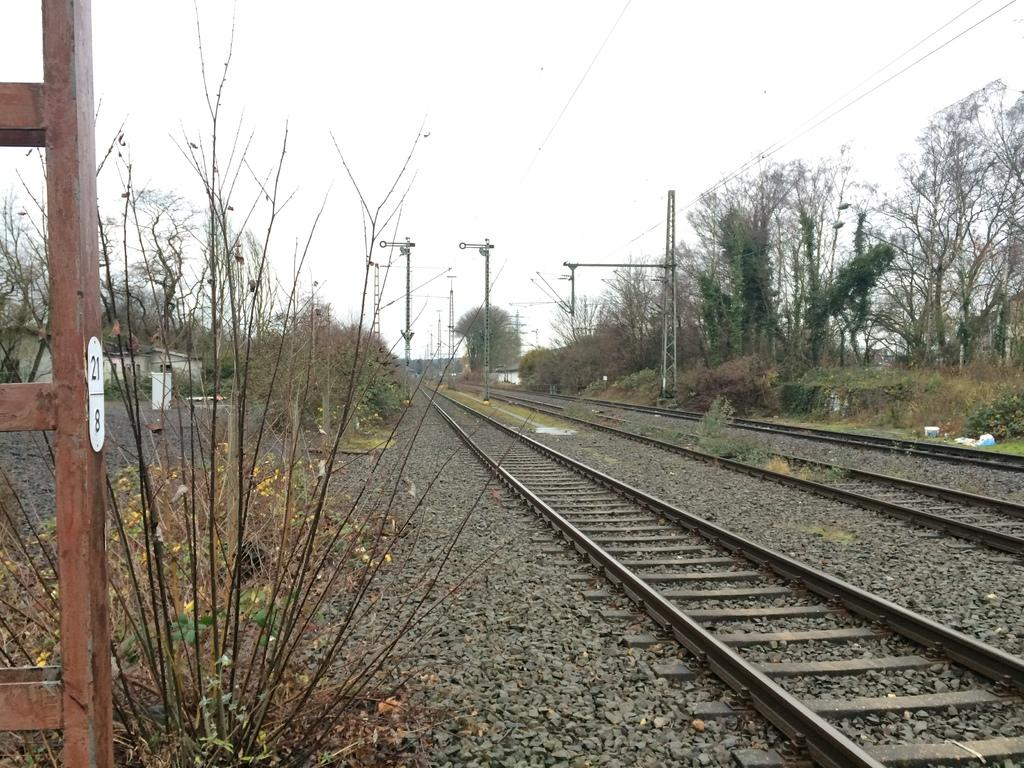What is the main feature in the image? There is a track in the image. What can be seen near the track? There are many poles and trees near the track. What is visible in the background of the image? The sky is visible in the background of the image. How much liquid is present in the image? There is no liquid present in the image; it primarily features a track, poles, trees, and the sky. 